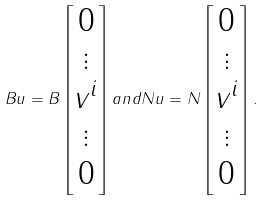<formula> <loc_0><loc_0><loc_500><loc_500>B u = B \begin{bmatrix} 0 \\ \vdots \\ v ^ { i } \\ \vdots \\ 0 \end{bmatrix} a n d N u = N \begin{bmatrix} 0 \\ \vdots \\ v ^ { i } \\ \vdots \\ 0 \end{bmatrix} .</formula> 